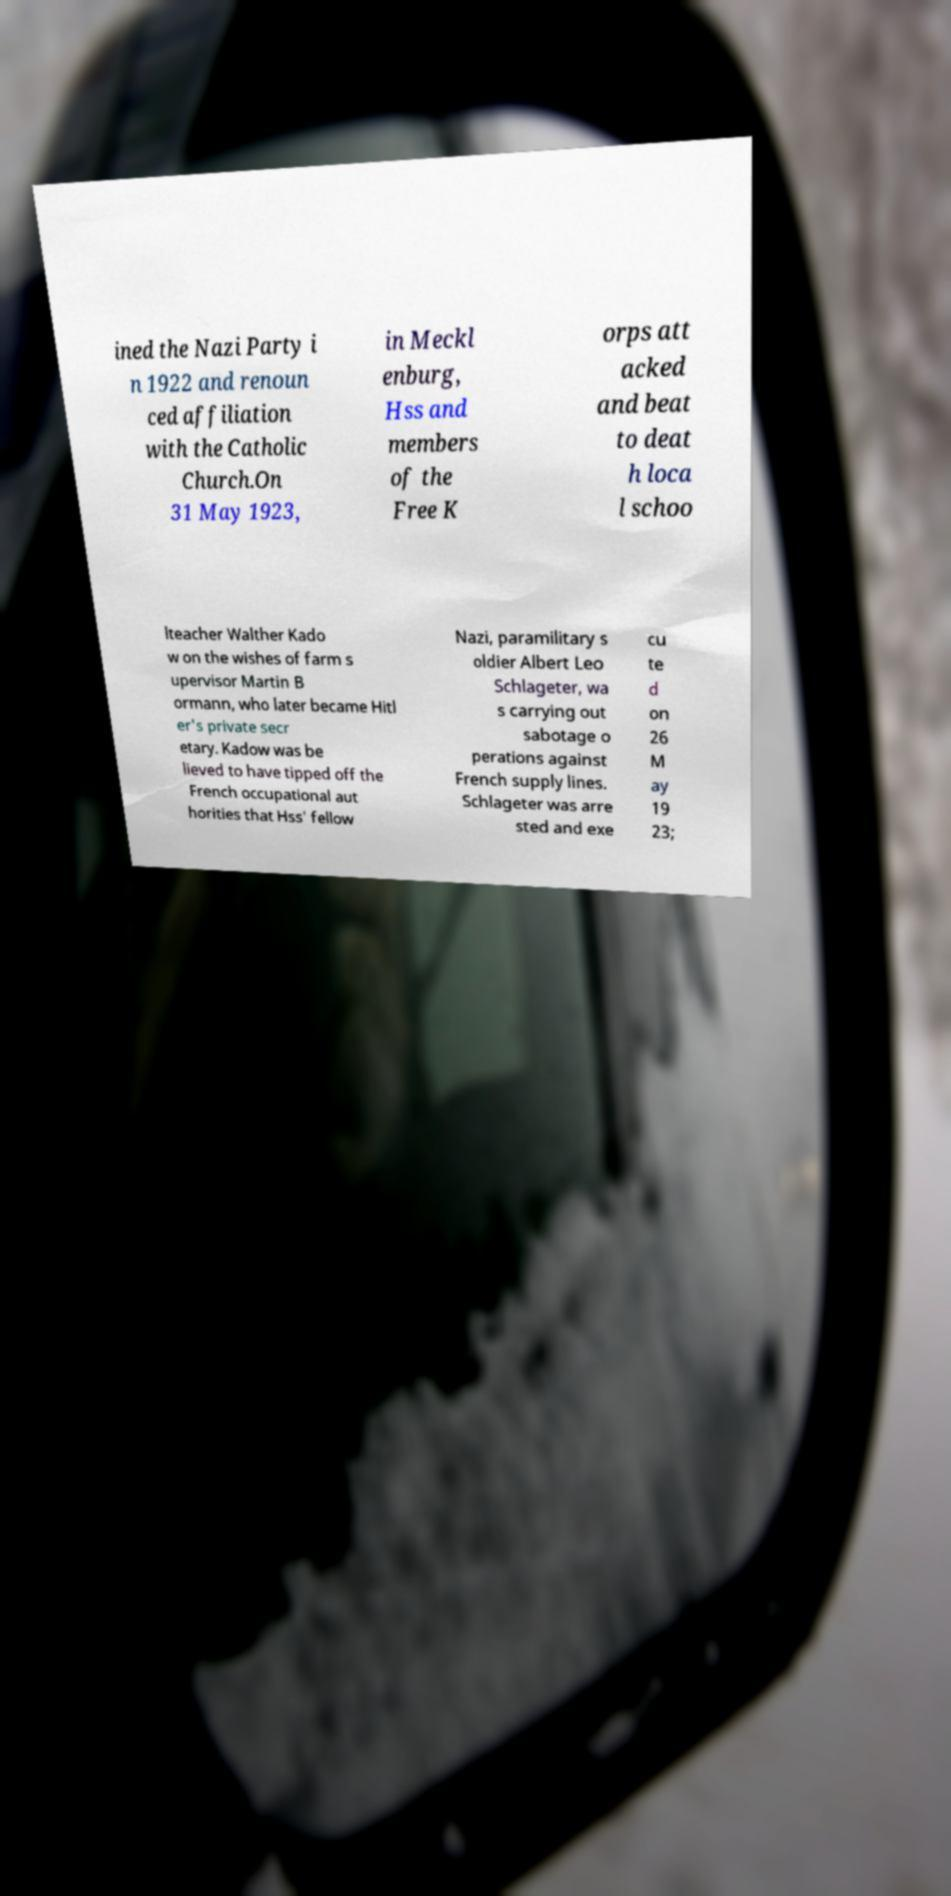Can you read and provide the text displayed in the image?This photo seems to have some interesting text. Can you extract and type it out for me? ined the Nazi Party i n 1922 and renoun ced affiliation with the Catholic Church.On 31 May 1923, in Meckl enburg, Hss and members of the Free K orps att acked and beat to deat h loca l schoo lteacher Walther Kado w on the wishes of farm s upervisor Martin B ormann, who later became Hitl er's private secr etary. Kadow was be lieved to have tipped off the French occupational aut horities that Hss' fellow Nazi, paramilitary s oldier Albert Leo Schlageter, wa s carrying out sabotage o perations against French supply lines. Schlageter was arre sted and exe cu te d on 26 M ay 19 23; 